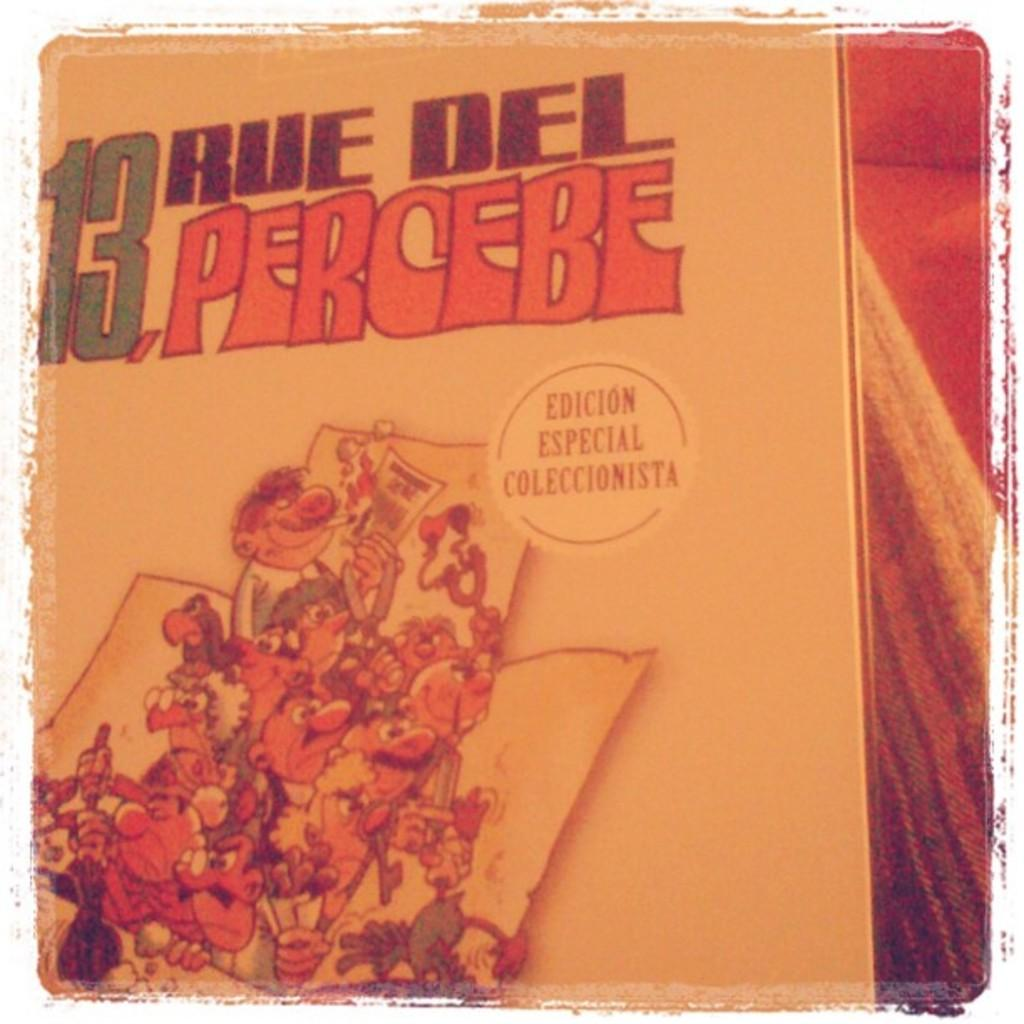<image>
Provide a brief description of the given image. The cover of the book 13 Rue Del Percebe 